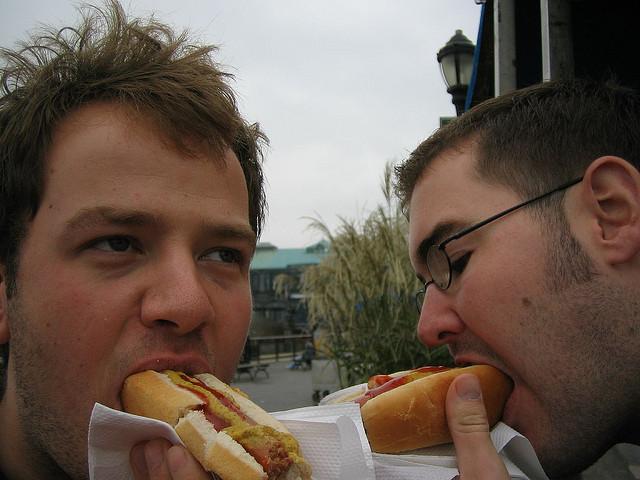How many of these men are wearing glasses?
Give a very brief answer. 1. How many people are eating?
Give a very brief answer. 2. How many people are there?
Give a very brief answer. 2. How many hot dogs are there?
Give a very brief answer. 2. 